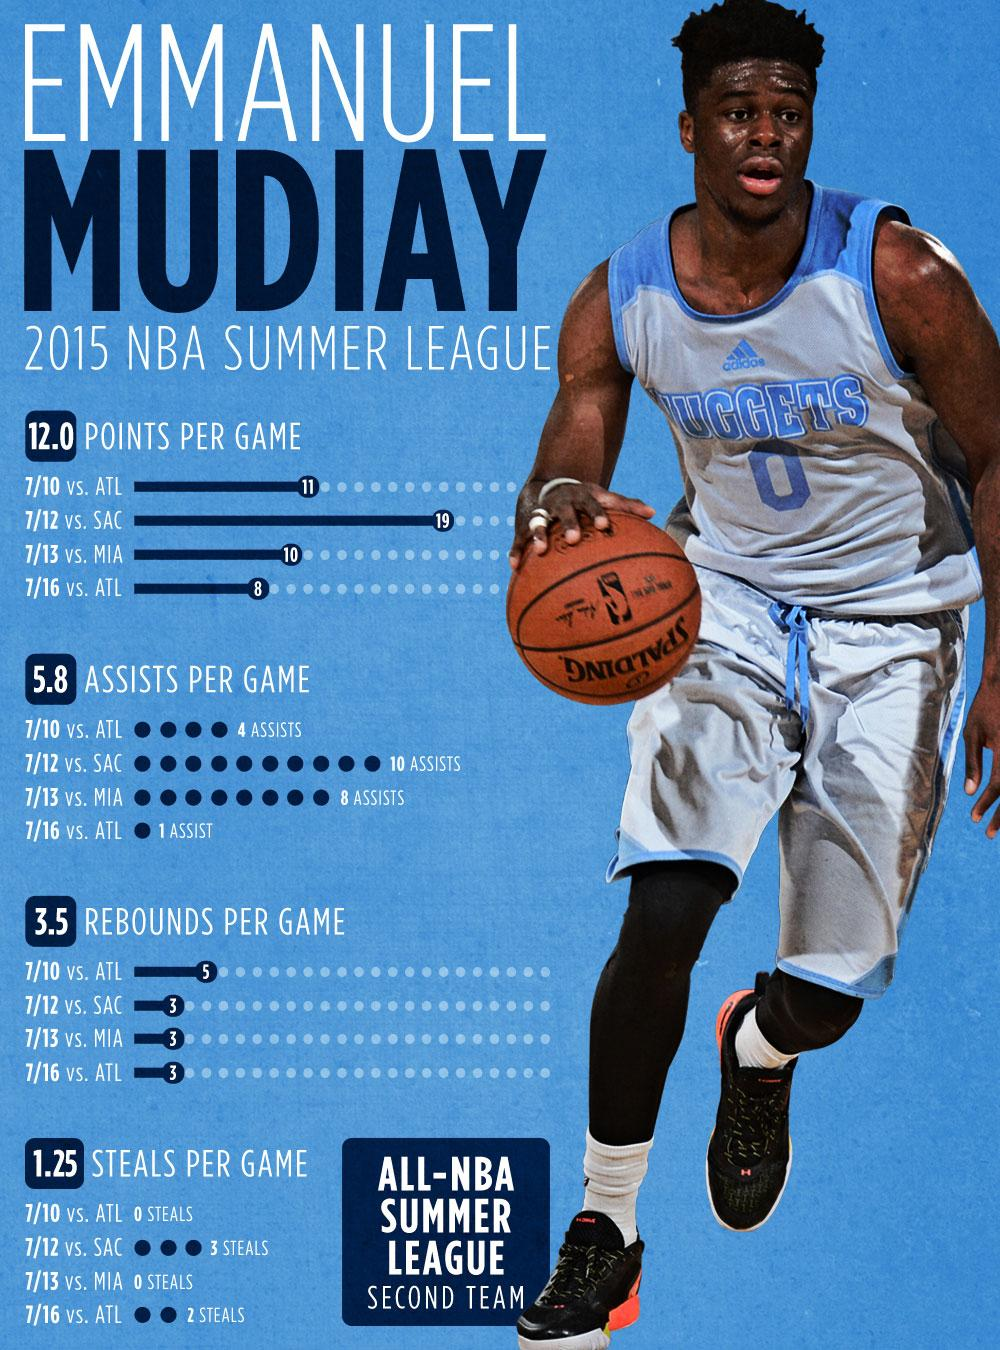Indicate a few pertinent items in this graphic. Emmanuel Mudiay averaged 14 rebounds per game, the total number of rebounds per game. Emmanuel Mudiay has an average of 5 steals per game, a total that demonstrates his agility and quickness on the court. The total number of points per game for Emmanuel Mudiay is 48. Emmanuel Mudiay has an average of 23 assists per game, which is the total number of assists per game from him, 